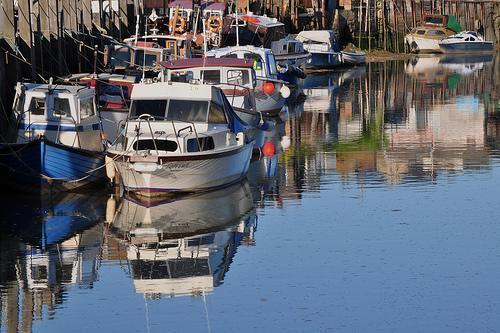How many boats have blue on them?
Give a very brief answer. 1. How many lifesavers are in the picture?
Give a very brief answer. 2. How many blue boats are riding in the river?
Give a very brief answer. 0. How many lobsters can be seen swimming in the water?
Give a very brief answer. 0. 